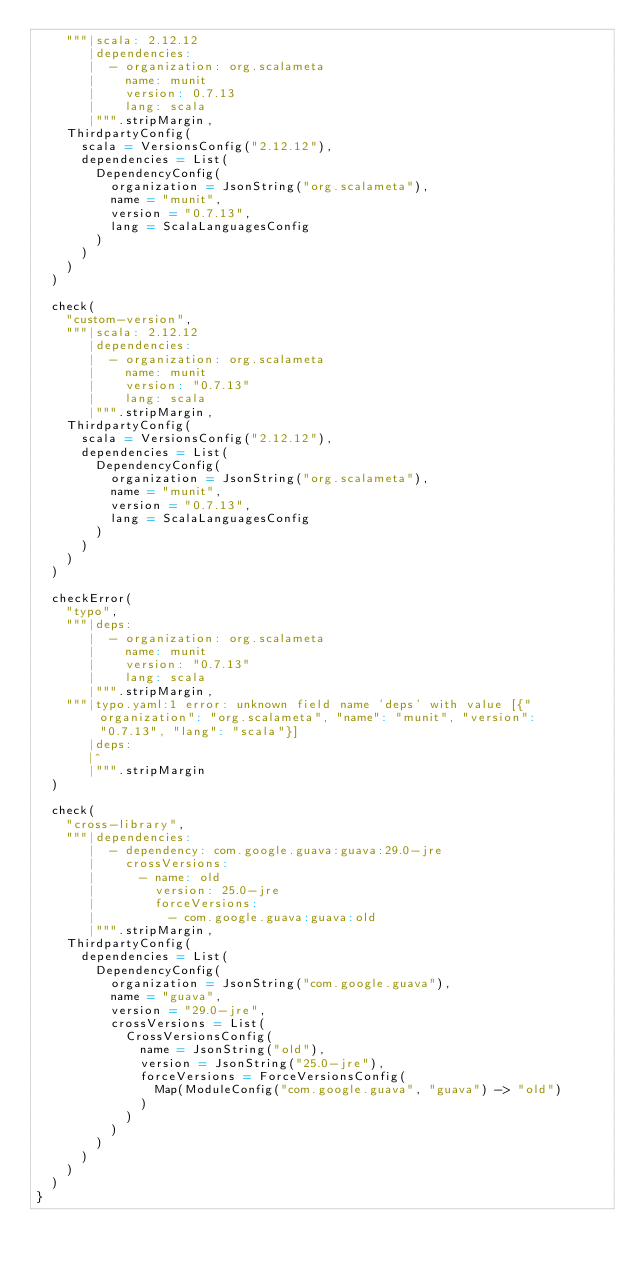<code> <loc_0><loc_0><loc_500><loc_500><_Scala_>    """|scala: 2.12.12
       |dependencies:
       |  - organization: org.scalameta
       |    name: munit
       |    version: 0.7.13
       |    lang: scala
       |""".stripMargin,
    ThirdpartyConfig(
      scala = VersionsConfig("2.12.12"),
      dependencies = List(
        DependencyConfig(
          organization = JsonString("org.scalameta"),
          name = "munit",
          version = "0.7.13",
          lang = ScalaLanguagesConfig
        )
      )
    )
  )

  check(
    "custom-version",
    """|scala: 2.12.12
       |dependencies:
       |  - organization: org.scalameta
       |    name: munit
       |    version: "0.7.13"
       |    lang: scala
       |""".stripMargin,
    ThirdpartyConfig(
      scala = VersionsConfig("2.12.12"),
      dependencies = List(
        DependencyConfig(
          organization = JsonString("org.scalameta"),
          name = "munit",
          version = "0.7.13",
          lang = ScalaLanguagesConfig
        )
      )
    )
  )

  checkError(
    "typo",
    """|deps:
       |  - organization: org.scalameta
       |    name: munit
       |    version: "0.7.13"
       |    lang: scala
       |""".stripMargin,
    """|typo.yaml:1 error: unknown field name 'deps' with value [{"organization": "org.scalameta", "name": "munit", "version": "0.7.13", "lang": "scala"}]
       |deps:
       |^
       |""".stripMargin
  )

  check(
    "cross-library",
    """|dependencies:
       |  - dependency: com.google.guava:guava:29.0-jre
       |    crossVersions:
       |      - name: old
       |        version: 25.0-jre
       |        forceVersions:
       |          - com.google.guava:guava:old
       |""".stripMargin,
    ThirdpartyConfig(
      dependencies = List(
        DependencyConfig(
          organization = JsonString("com.google.guava"),
          name = "guava",
          version = "29.0-jre",
          crossVersions = List(
            CrossVersionsConfig(
              name = JsonString("old"),
              version = JsonString("25.0-jre"),
              forceVersions = ForceVersionsConfig(
                Map(ModuleConfig("com.google.guava", "guava") -> "old")
              )
            )
          )
        )
      )
    )
  )
}
</code> 